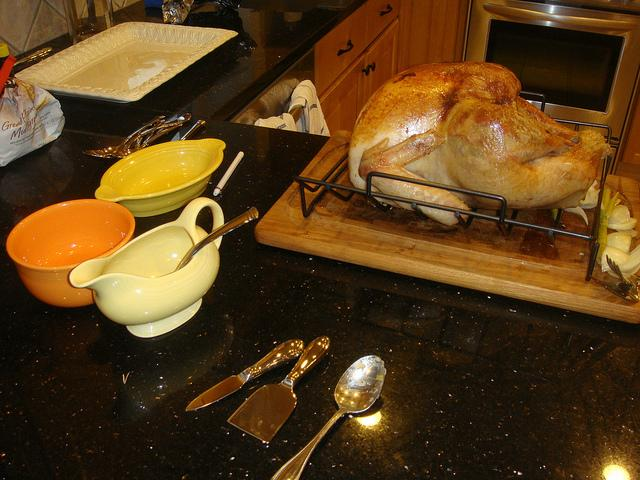What type of animal is being prepared? Please explain your reasoning. bird. There is a turkey on the cutting board. 